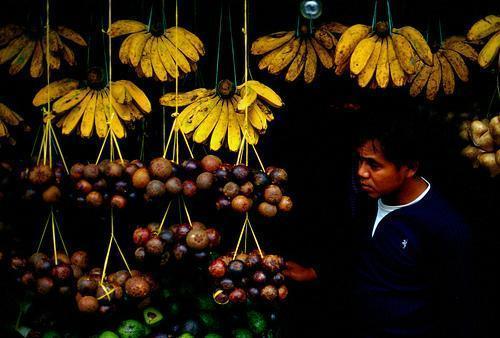How many people are in the picture?
Give a very brief answer. 1. 